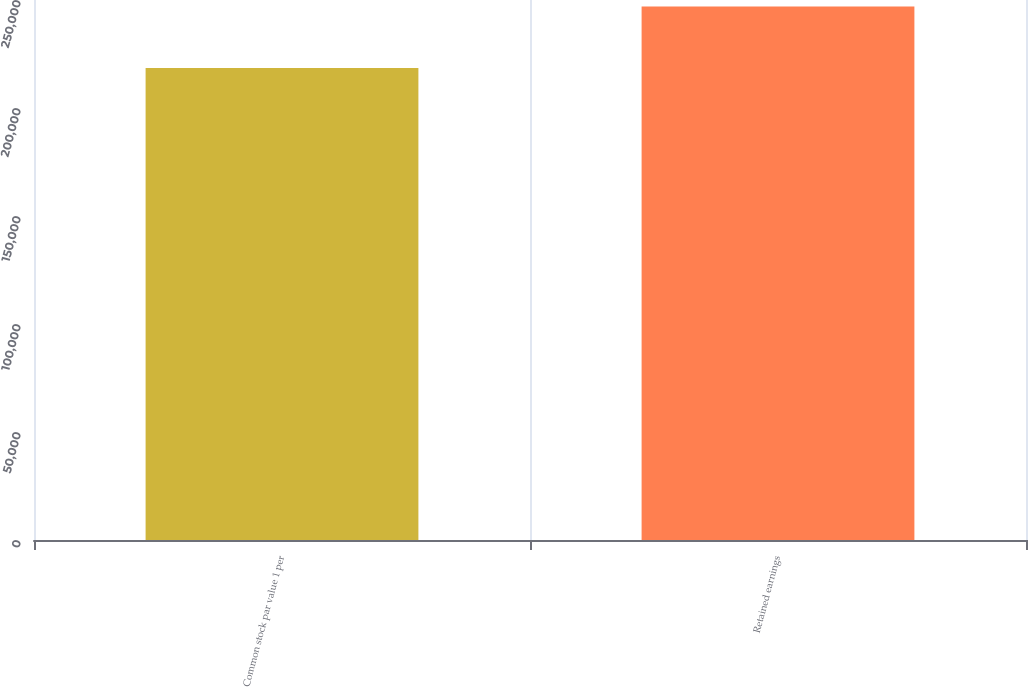<chart> <loc_0><loc_0><loc_500><loc_500><bar_chart><fcel>Common stock par value 1 per<fcel>Retained earnings<nl><fcel>218483<fcel>247042<nl></chart> 